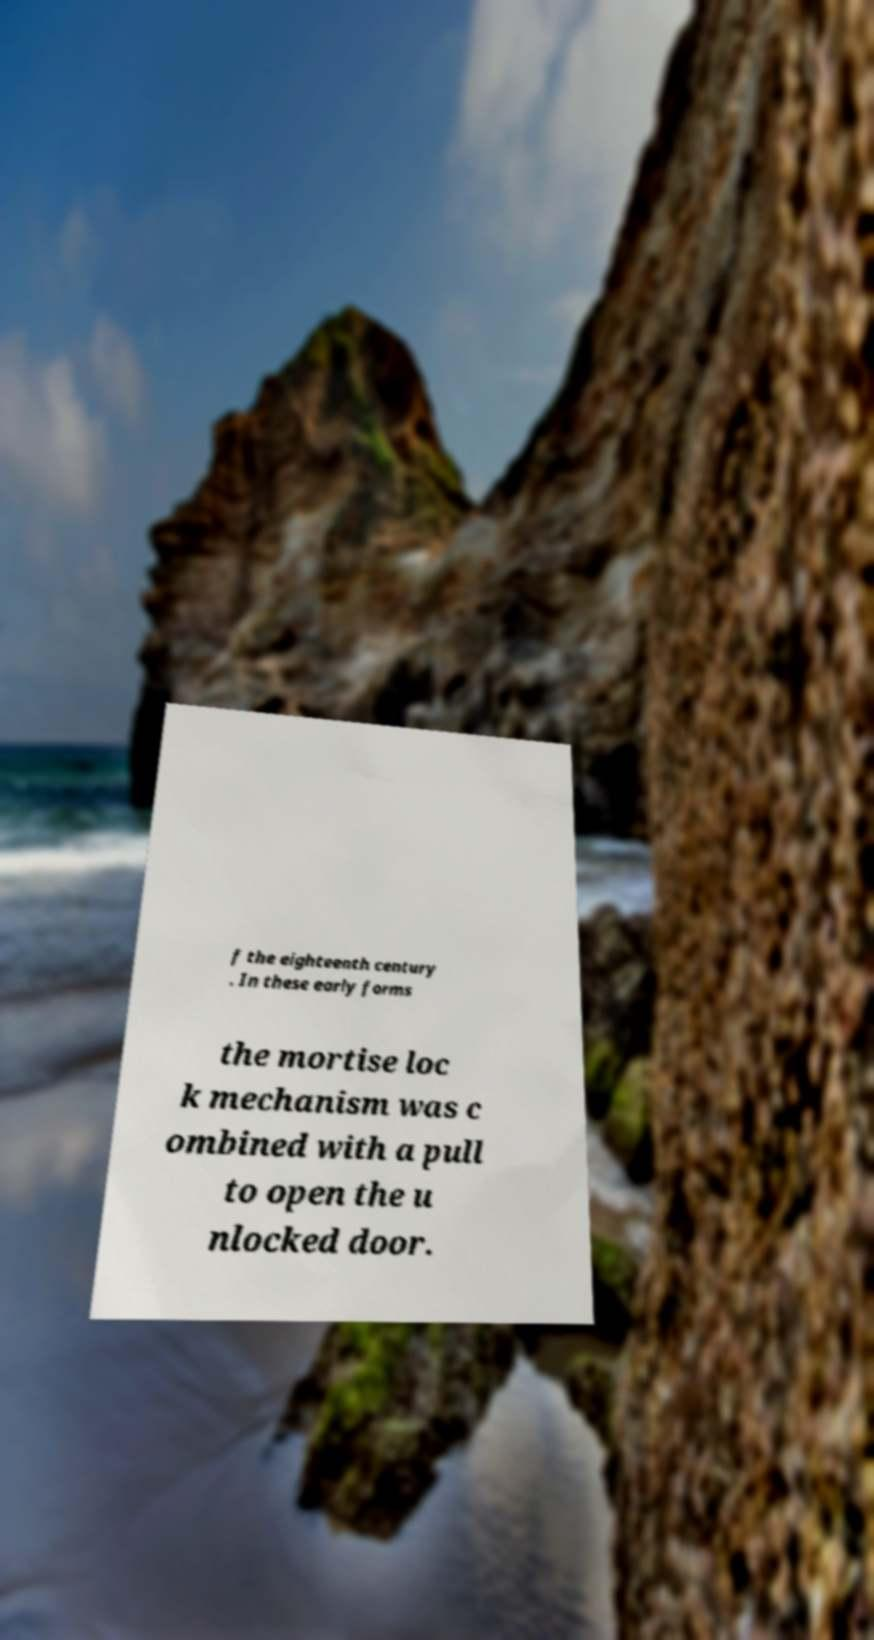For documentation purposes, I need the text within this image transcribed. Could you provide that? f the eighteenth century . In these early forms the mortise loc k mechanism was c ombined with a pull to open the u nlocked door. 